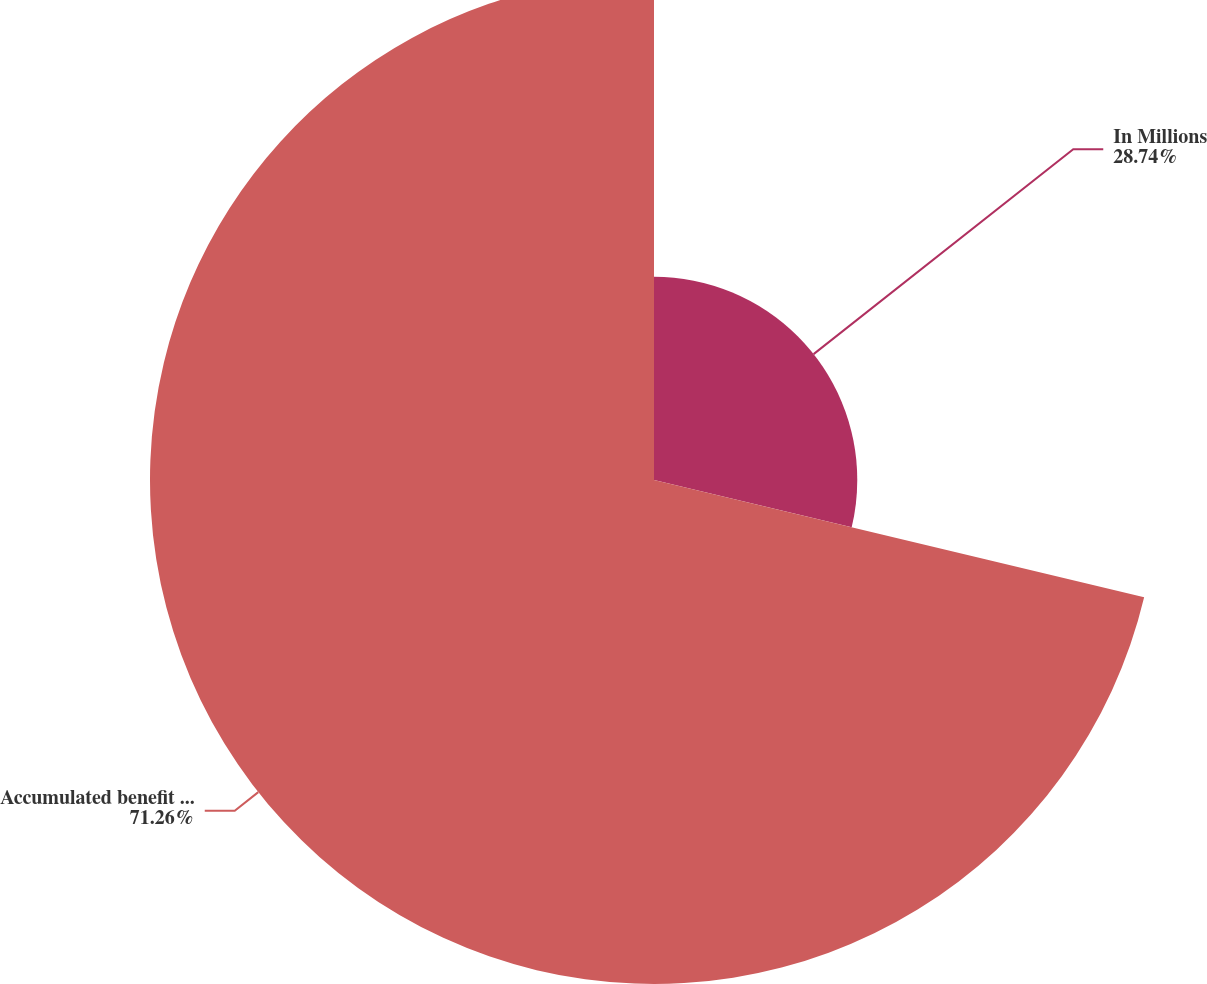<chart> <loc_0><loc_0><loc_500><loc_500><pie_chart><fcel>In Millions<fcel>Accumulated benefit obligation<nl><fcel>28.74%<fcel>71.26%<nl></chart> 